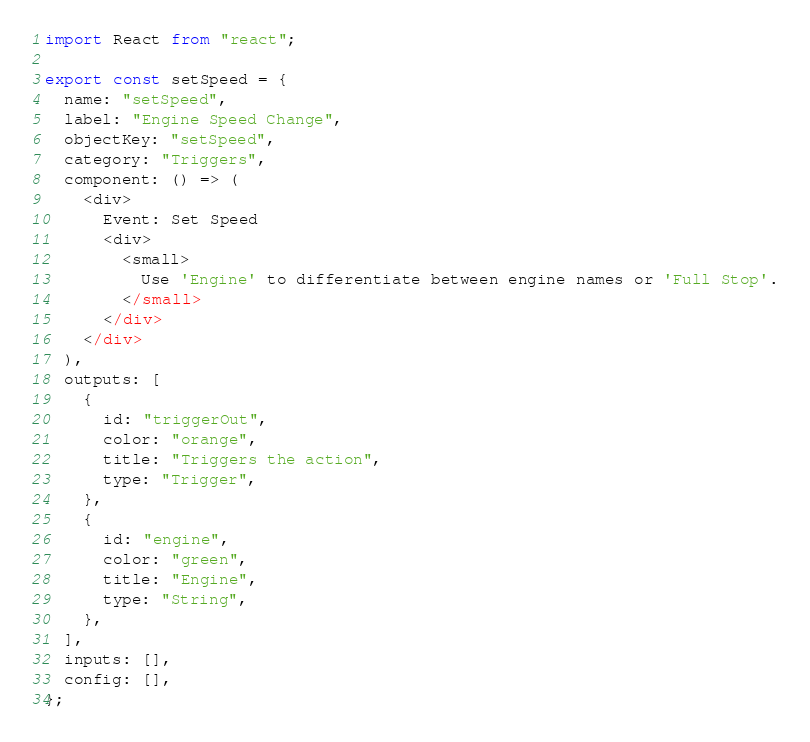Convert code to text. <code><loc_0><loc_0><loc_500><loc_500><_JavaScript_>import React from "react";

export const setSpeed = {
  name: "setSpeed",
  label: "Engine Speed Change",
  objectKey: "setSpeed",
  category: "Triggers",
  component: () => (
    <div>
      Event: Set Speed
      <div>
        <small>
          Use 'Engine' to differentiate between engine names or 'Full Stop'.
        </small>
      </div>
    </div>
  ),
  outputs: [
    {
      id: "triggerOut",
      color: "orange",
      title: "Triggers the action",
      type: "Trigger",
    },
    {
      id: "engine",
      color: "green",
      title: "Engine",
      type: "String",
    },
  ],
  inputs: [],
  config: [],
};
</code> 